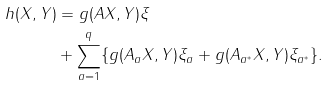Convert formula to latex. <formula><loc_0><loc_0><loc_500><loc_500>h ( X , Y ) & = g ( A X , Y ) \xi \\ & + \sum _ { a = 1 } ^ { q } \{ g ( A _ { a } X , Y ) \xi _ { a } + g ( A _ { a ^ { * } } X , Y ) \xi _ { a ^ { * } } \} .</formula> 